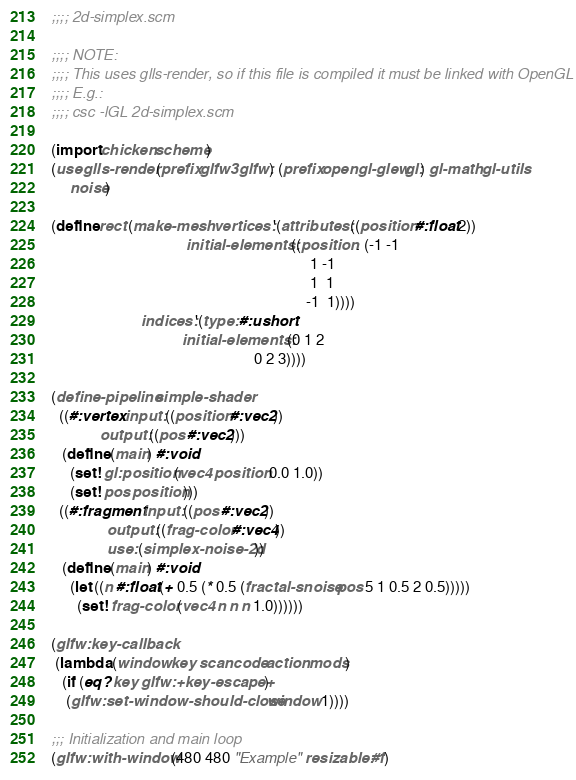<code> <loc_0><loc_0><loc_500><loc_500><_Scheme_>;;;; 2d-simplex.scm

;;;; NOTE:
;;;; This uses glls-render, so if this file is compiled it must be linked with OpenGL
;;;; E.g.:
;;;; csc -lGL 2d-simplex.scm

(import chicken scheme)
(use glls-render (prefix glfw3 glfw:) (prefix opengl-glew gl:) gl-math gl-utils
     noise)

(define rect (make-mesh vertices: '(attributes: ((position #:float 2))
                                    initial-elements: ((position . (-1 -1
                                                                     1 -1
                                                                     1  1
                                                                    -1  1))))
                        indices: '(type: #:ushort
                                   initial-elements: (0 1 2
                                                      0 2 3))))

(define-pipeline simple-shader
  ((#:vertex input: ((position #:vec2))
             output: ((pos #:vec2))) 
   (define (main) #:void
     (set! gl:position (vec4 position 0.0 1.0))
     (set! pos position)))
  ((#:fragment input: ((pos #:vec2))
               output: ((frag-color #:vec4))
               use: (simplex-noise-2d))
   (define (main) #:void
     (let ((n #:float (+ 0.5 (* 0.5 (fractal-snoise pos 5 1 0.5 2 0.5)))))
       (set! frag-color (vec4 n n n 1.0))))))

(glfw:key-callback
 (lambda (window key scancode action mods)
   (if (eq? key glfw:+key-escape+)
    (glfw:set-window-should-close window 1))))

;;; Initialization and main loop
(glfw:with-window (480 480 "Example" resizable: #f)</code> 